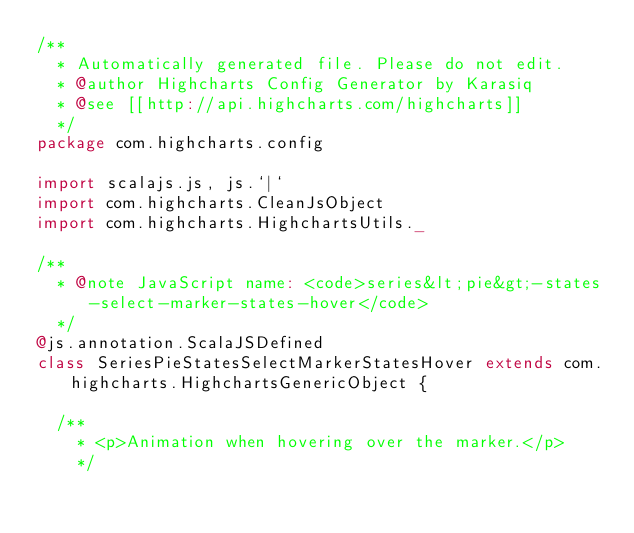Convert code to text. <code><loc_0><loc_0><loc_500><loc_500><_Scala_>/**
  * Automatically generated file. Please do not edit.
  * @author Highcharts Config Generator by Karasiq
  * @see [[http://api.highcharts.com/highcharts]]
  */
package com.highcharts.config

import scalajs.js, js.`|`
import com.highcharts.CleanJsObject
import com.highcharts.HighchartsUtils._

/**
  * @note JavaScript name: <code>series&lt;pie&gt;-states-select-marker-states-hover</code>
  */
@js.annotation.ScalaJSDefined
class SeriesPieStatesSelectMarkerStatesHover extends com.highcharts.HighchartsGenericObject {

  /**
    * <p>Animation when hovering over the marker.</p>
    */</code> 